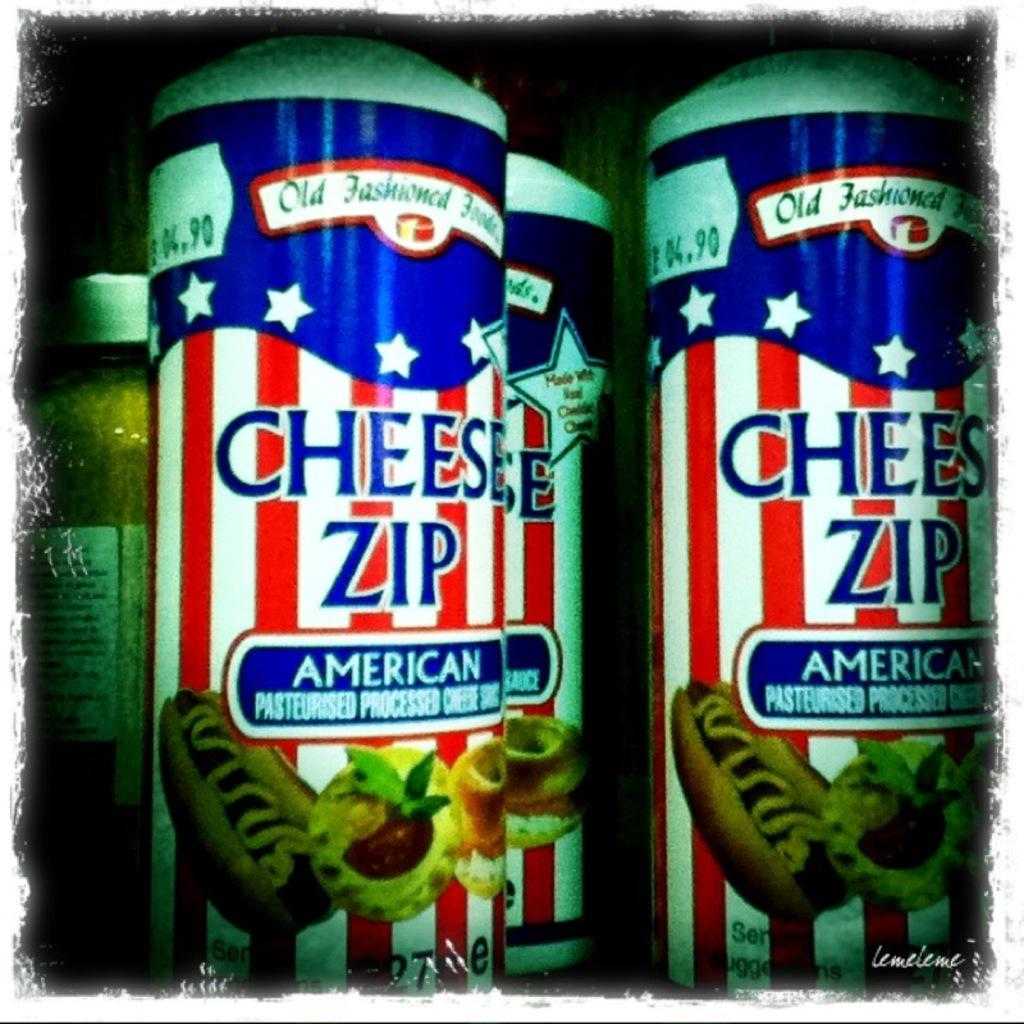What flavor of cheese are these?
Your response must be concise. American. 